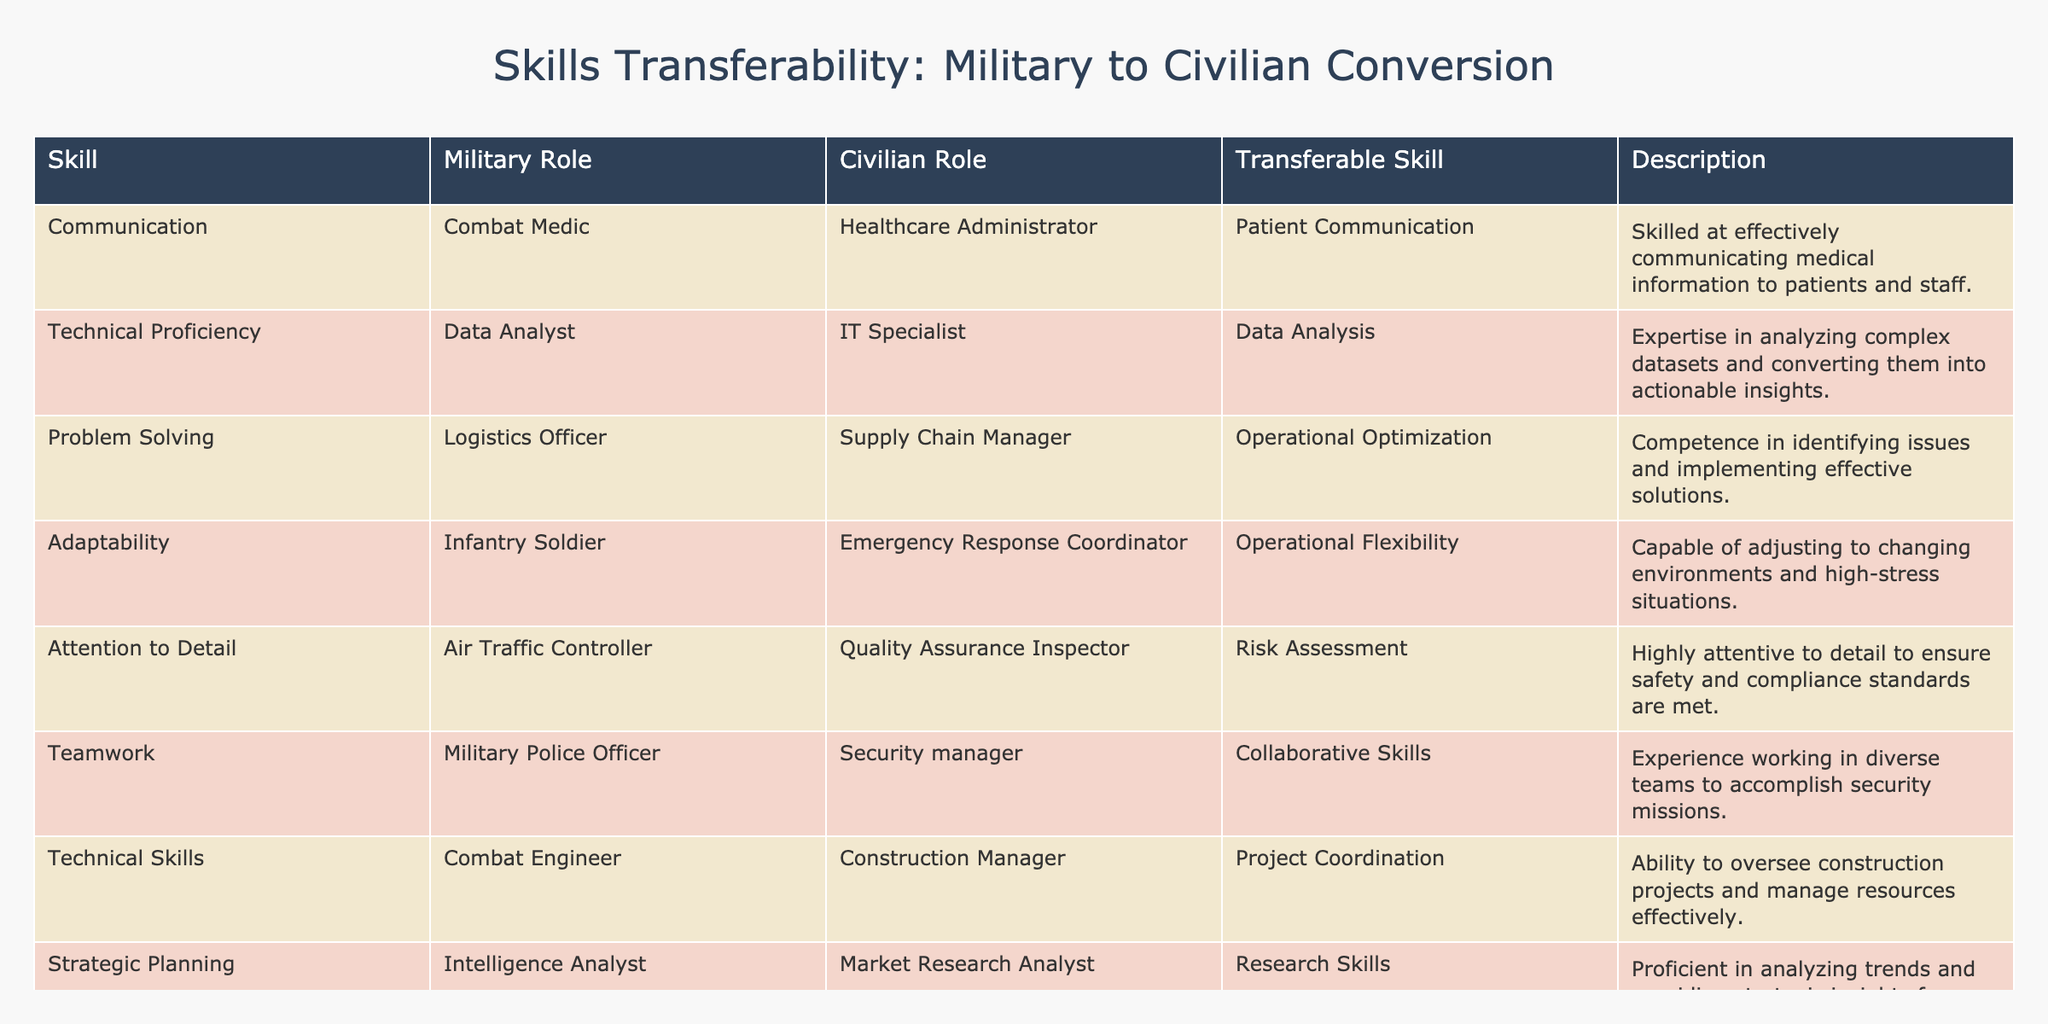What civilian role corresponds to the military role of a Combat Medic? The table indicates that the military role of a Combat Medic corresponds to the civilian role of a Healthcare Administrator. This is derived directly from the data in the "Military Role" and "Civilian Role" columns.
Answer: Healthcare Administrator Which transferable skill is associated with the military role of a Logistics Officer? According to the table, the transferable skill associated with the Logistics Officer is Operational Optimization. This is found by examining the specific entry for the Logistics Officer in the "Transferable Skill" column.
Answer: Operational Optimization How many military roles are listed in the table? There are 10 military roles listed in the table, one for each entry. Counting each entry under the "Military Role" column gives us the total.
Answer: 10 Is Attention to Detail a transferable skill for military personnel transitioning to civilian jobs? Yes, Attention to Detail is indeed a transferable skill as it is explicitly listed in the table. The description further confirms its relevance to roles such as Quality Assurance Inspector.
Answer: Yes What is the difference between the number of roles related to Communication and Technical Proficiency? There is 1 military role related to Communication (Combat Medic) and 1 related to Technical Proficiency (Data Analyst). The difference is calculated as (1 - 1 = 0). Thus, there are no more roles related to one than the other.
Answer: 0 Which civilian role requires the transferable skill of Teamwork, and how does this relate to its associated military role? The civilian role that requires the transferable skill of Teamwork is Security Manager, which relates to the military role of Military Police Officer. This can be seen by linking the roles in the respective columns.
Answer: Security Manager List the transferable skills associated with an Intelligence Analyst. The table shows that an Intelligence Analyst corresponds to the transferable skill of Research Skills, as listed in the row matching this military role.
Answer: Research Skills Are there more transferable skills associated with Infantry Soldier than with Air Traffic Controller? Yes, the Infantry Soldier has one transferable skill (Operational Flexibility) while Air Traffic Controller also has one (Risk Assessment). Thus, they are equal. Checking the rows for both military roles, we confirm that neither has more.
Answer: No What is the description of the transferable skill related to Logistical Planning? The description for the transferable skill related to Logistical Planning is "Skills in planning and managing logistical operations and inventory systems." This can be found by looking at the corresponding row in the table.
Answer: Skills in planning and managing logistical operations and inventory systems 